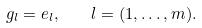Convert formula to latex. <formula><loc_0><loc_0><loc_500><loc_500>g _ { l } = e _ { l } , \quad l = ( 1 , \dots , m ) .</formula> 